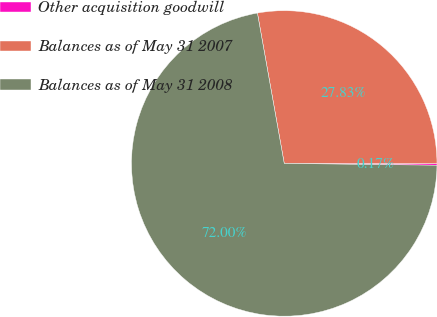Convert chart. <chart><loc_0><loc_0><loc_500><loc_500><pie_chart><fcel>Other acquisition goodwill<fcel>Balances as of May 31 2007<fcel>Balances as of May 31 2008<nl><fcel>0.17%<fcel>27.83%<fcel>72.01%<nl></chart> 